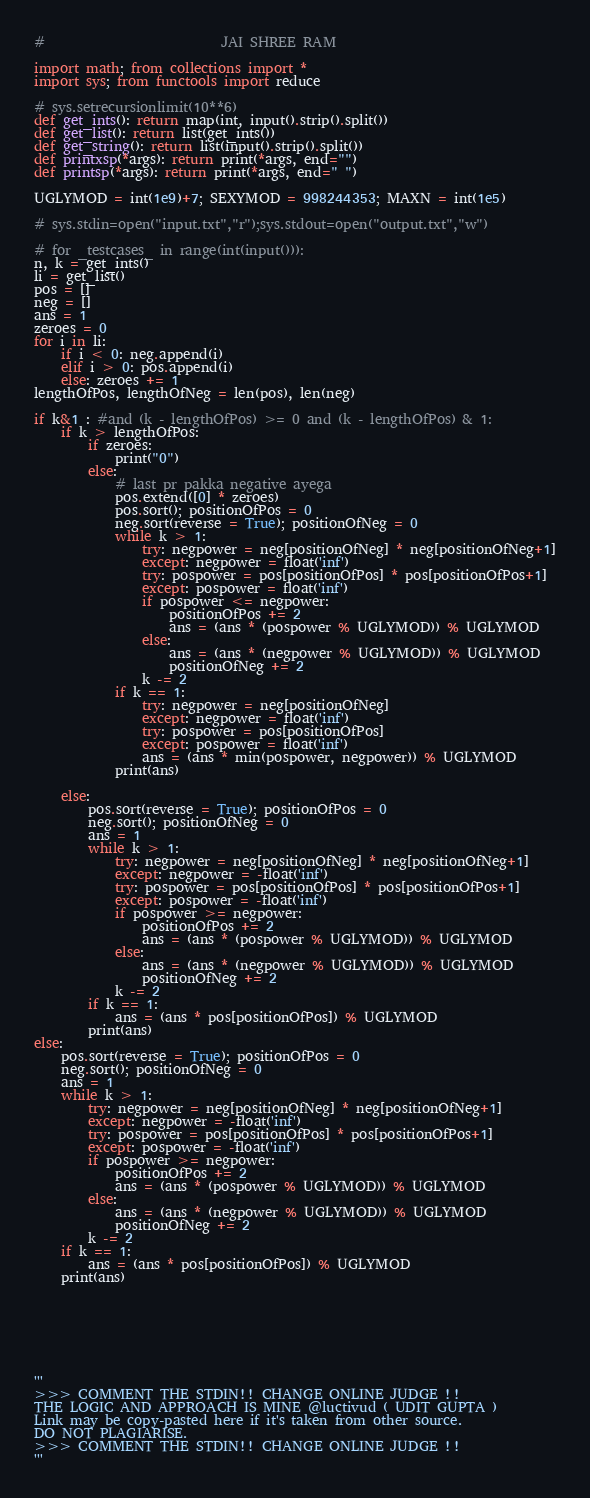Convert code to text. <code><loc_0><loc_0><loc_500><loc_500><_Python_>#                          JAI SHREE RAM

import math; from collections import *
import sys; from functools import reduce

# sys.setrecursionlimit(10**6)
def get_ints(): return map(int, input().strip().split())
def get_list(): return list(get_ints())
def get_string(): return list(input().strip().split())
def printxsp(*args): return print(*args, end="")
def printsp(*args): return print(*args, end=" ")

UGLYMOD = int(1e9)+7; SEXYMOD = 998244353; MAXN = int(1e5)

# sys.stdin=open("input.txt","r");sys.stdout=open("output.txt","w")

# for _testcases_ in range(int(input())):
n, k = get_ints()
li = get_list()
pos = []
neg = []
ans = 1
zeroes = 0
for i in li:
    if i < 0: neg.append(i)
    elif i > 0: pos.append(i)
    else: zeroes += 1
lengthOfPos, lengthOfNeg = len(pos), len(neg)

if k&1 : #and (k - lengthOfPos) >= 0 and (k - lengthOfPos) & 1:
    if k > lengthOfPos:
        if zeroes:
            print("0")
        else:
            # last pr pakka negative ayega
            pos.extend([0] * zeroes)
            pos.sort(); positionOfPos = 0
            neg.sort(reverse = True); positionOfNeg = 0
            while k > 1:
                try: negpower = neg[positionOfNeg] * neg[positionOfNeg+1]
                except: negpower = float('inf')
                try: pospower = pos[positionOfPos] * pos[positionOfPos+1]
                except: pospower = float('inf')
                if pospower <= negpower:
                    positionOfPos += 2
                    ans = (ans * (pospower % UGLYMOD)) % UGLYMOD
                else:
                    ans = (ans * (negpower % UGLYMOD)) % UGLYMOD
                    positionOfNeg += 2
                k -= 2
            if k == 1:
                try: negpower = neg[positionOfNeg]
                except: negpower = float('inf')
                try: pospower = pos[positionOfPos]
                except: pospower = float('inf')
                ans = (ans * min(pospower, negpower)) % UGLYMOD
            print(ans)
            
    else:
        pos.sort(reverse = True); positionOfPos = 0
        neg.sort(); positionOfNeg = 0
        ans = 1
        while k > 1:
            try: negpower = neg[positionOfNeg] * neg[positionOfNeg+1]
            except: negpower = -float('inf')
            try: pospower = pos[positionOfPos] * pos[positionOfPos+1]
            except: pospower = -float('inf')
            if pospower >= negpower:
                positionOfPos += 2
                ans = (ans * (pospower % UGLYMOD)) % UGLYMOD
            else:
                ans = (ans * (negpower % UGLYMOD)) % UGLYMOD
                positionOfNeg += 2
            k -= 2
        if k == 1:
            ans = (ans * pos[positionOfPos]) % UGLYMOD
        print(ans)
else:
    pos.sort(reverse = True); positionOfPos = 0
    neg.sort(); positionOfNeg = 0
    ans = 1
    while k > 1:
        try: negpower = neg[positionOfNeg] * neg[positionOfNeg+1]
        except: negpower = -float('inf')
        try: pospower = pos[positionOfPos] * pos[positionOfPos+1]
        except: pospower = -float('inf')
        if pospower >= negpower:
            positionOfPos += 2
            ans = (ans * (pospower % UGLYMOD)) % UGLYMOD
        else:
            ans = (ans * (negpower % UGLYMOD)) % UGLYMOD
            positionOfNeg += 2
        k -= 2
    if k == 1:
        ans = (ans * pos[positionOfPos]) % UGLYMOD
    print(ans)







'''
>>> COMMENT THE STDIN!! CHANGE ONLINE JUDGE !!
THE LOGIC AND APPROACH IS MINE @luctivud ( UDIT GUPTA )
Link may be copy-pasted here if it's taken from other source.
DO NOT PLAGIARISE.
>>> COMMENT THE STDIN!! CHANGE ONLINE JUDGE !!
'''</code> 